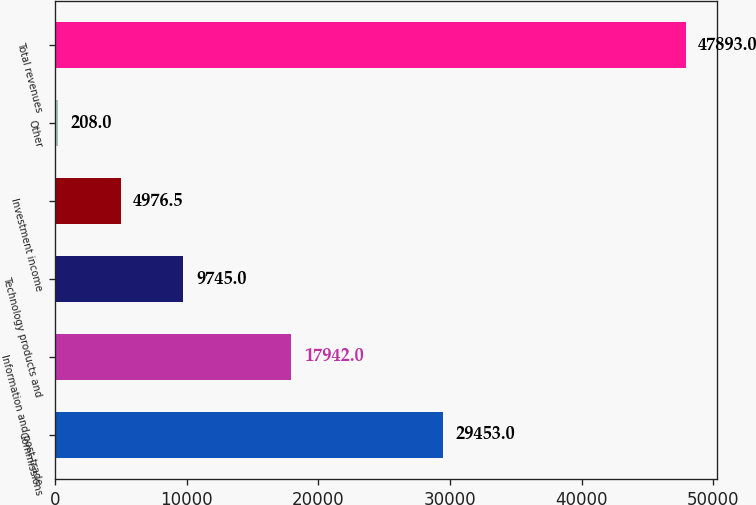Convert chart. <chart><loc_0><loc_0><loc_500><loc_500><bar_chart><fcel>Commissions<fcel>Information and post-trade<fcel>Technology products and<fcel>Investment income<fcel>Other<fcel>Total revenues<nl><fcel>29453<fcel>17942<fcel>9745<fcel>4976.5<fcel>208<fcel>47893<nl></chart> 